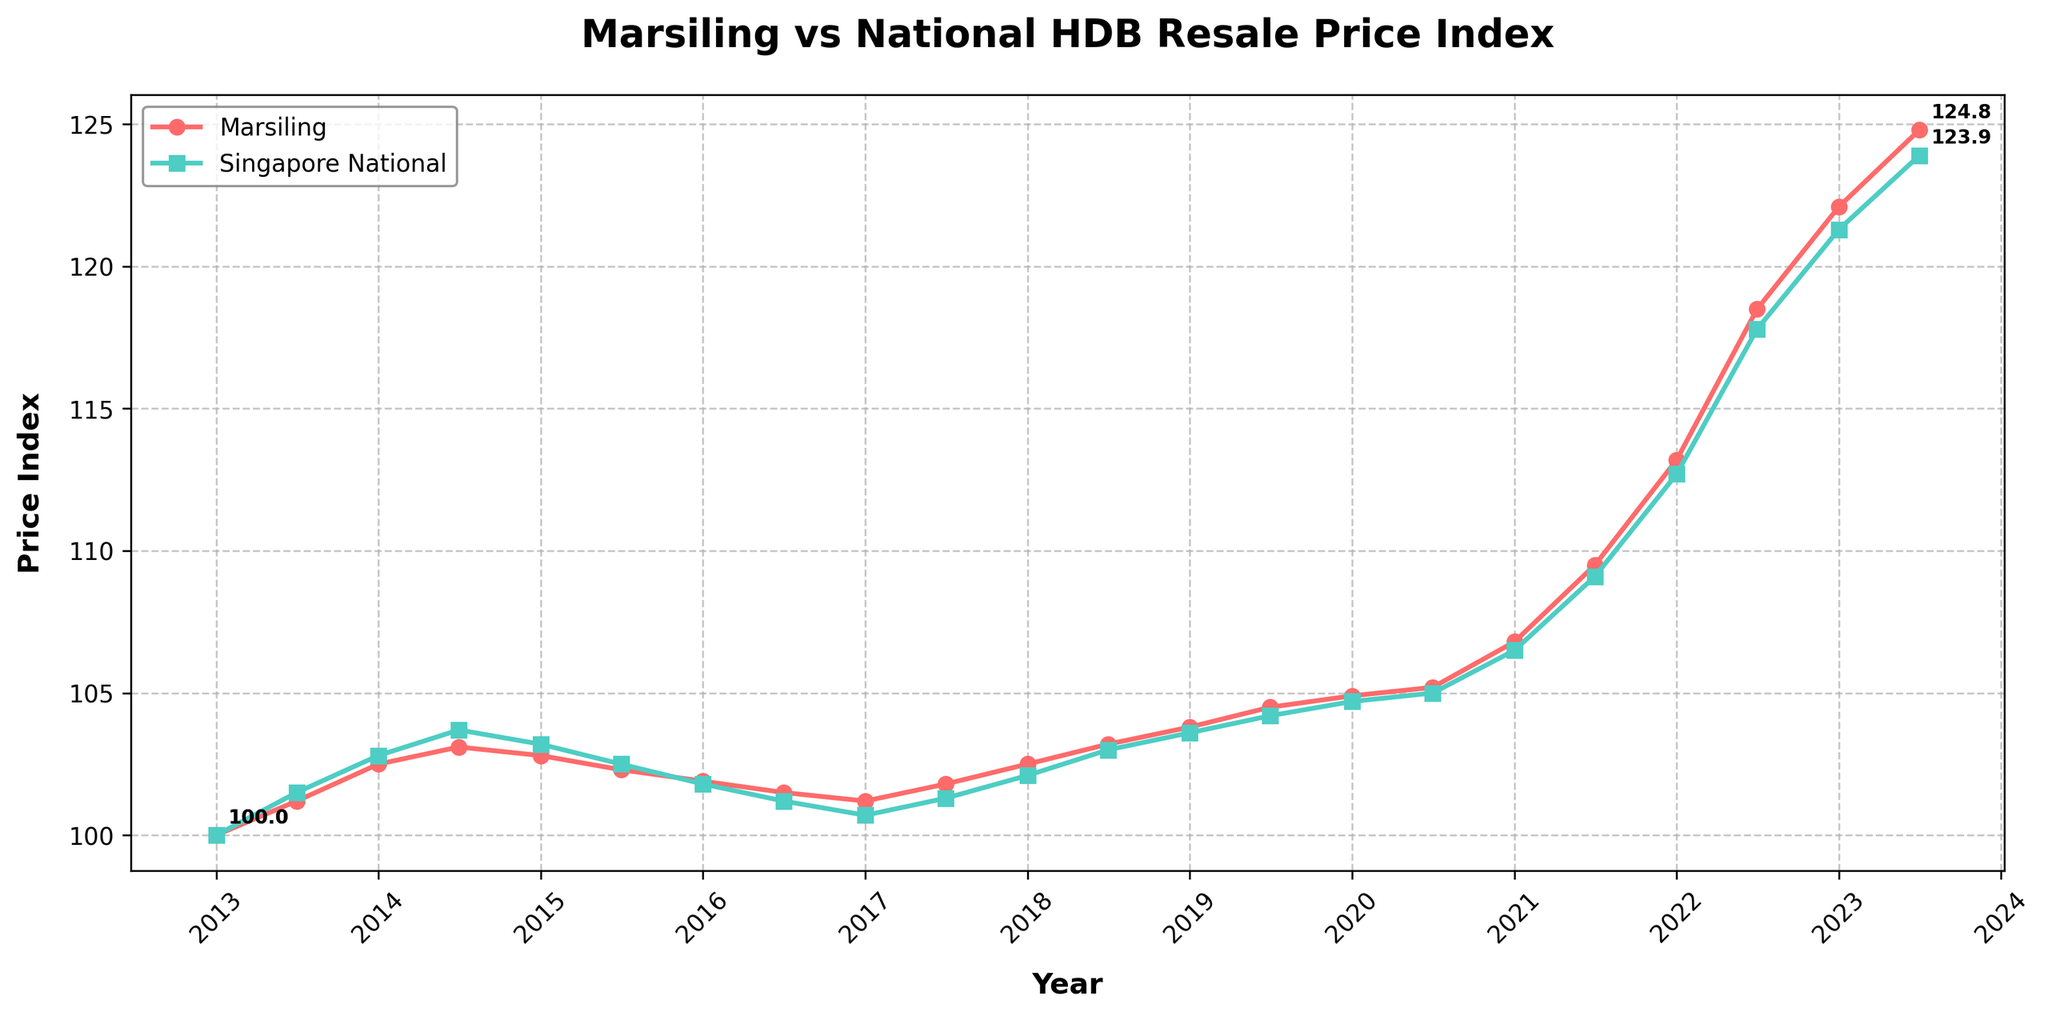What's the trend in the Marsiling HDB Resale Price Index from 2013 to 2023? The index shows an overall increasing trend over the decade. Starting from 100.0 in January 2013, it gradually increases year by year, reaching 124.8 by July 2023. The rise is consistent, with small fluctuations along the way.
Answer: Increasing trend How does the Marsiling HDB Resale Price Index in January 2023 compare to the Singapore National HDB Resale Price Index in the same month? In January 2023, Marsiling’s index stood at 122.1, while Singapore’s national index was at 121.3. Marsiling's index is slightly higher than the national average.
Answer: Marsiling is higher What is the average Marsiling HDB Resale Price Index over the decade? To find the average, sum all the Marsiling HDB Resale Price Index values from January 2013 to July 2023 and divide by the number of data points (21). The total is 2,160.1, and dividing by 21 gives approximately 102.9.
Answer: ~102.9 Between which two consecutive periods did Marsiling see the highest increase in its HDB Resale Price Index? Comparing consecutive periods, the largest increase is between January 2022 (113.2) and July 2022 (118.5). The increase is 118.5 - 113.2 = 5.3.
Answer: January 2022 to July 2022 Which period saw a decline or the smallest growth in the Marsiling HDB Resale Price Index, and what was the percentage change? The smallest growth is between July 2014 (103.1) and January 2015 (102.8). The percentage change is ((102.8 - 103.1) / 103.1) * 100 = -0.29%.
Answer: July 2014 to January 2015, -0.29% Which data set experienced less volatility in the HDB Resale Price Index over the decade, Marsiling or the national average? The national average shows smoother changes over the decade compared to Marsiling, which has more noticeable fluctuations.
Answer: Singapore national average In what year did Marsiling first surpass the Singapore National HDB Resale Price Index? Marsiling first surpassed the national index in January 2016, with indices of 101.9 and 101.8, respectively.
Answer: 2016 By how much did Marsiling's HDB Resale Price Index increase between January 2020 and July 2023? In January 2020, the index was 104.9. By July 2023, it was 124.8. The increase is 124.8 - 104.9 = 19.9 points.
Answer: 19.9 points What can you infer about the overall trend of the Singapore National HDB Resale Price Index from the graph? The national index shows a consistent upward trend with slight variations, starting at 100.0 in January 2013 and reaching 123.9 by July 2023.
Answer: Upward trend 